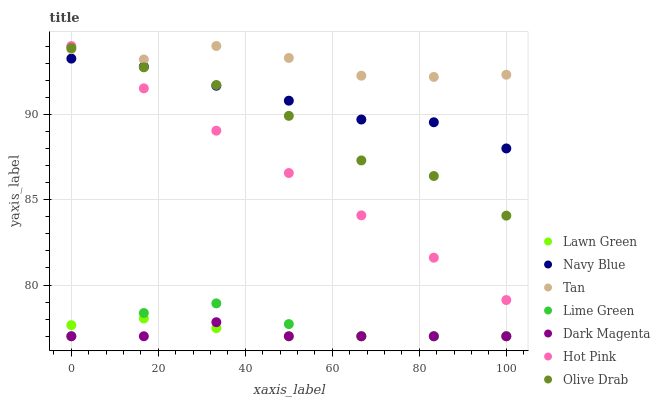Does Dark Magenta have the minimum area under the curve?
Answer yes or no. Yes. Does Tan have the maximum area under the curve?
Answer yes or no. Yes. Does Navy Blue have the minimum area under the curve?
Answer yes or no. No. Does Navy Blue have the maximum area under the curve?
Answer yes or no. No. Is Hot Pink the smoothest?
Answer yes or no. Yes. Is Olive Drab the roughest?
Answer yes or no. Yes. Is Dark Magenta the smoothest?
Answer yes or no. No. Is Dark Magenta the roughest?
Answer yes or no. No. Does Lawn Green have the lowest value?
Answer yes or no. Yes. Does Navy Blue have the lowest value?
Answer yes or no. No. Does Tan have the highest value?
Answer yes or no. Yes. Does Navy Blue have the highest value?
Answer yes or no. No. Is Dark Magenta less than Hot Pink?
Answer yes or no. Yes. Is Navy Blue greater than Lawn Green?
Answer yes or no. Yes. Does Dark Magenta intersect Lawn Green?
Answer yes or no. Yes. Is Dark Magenta less than Lawn Green?
Answer yes or no. No. Is Dark Magenta greater than Lawn Green?
Answer yes or no. No. Does Dark Magenta intersect Hot Pink?
Answer yes or no. No. 